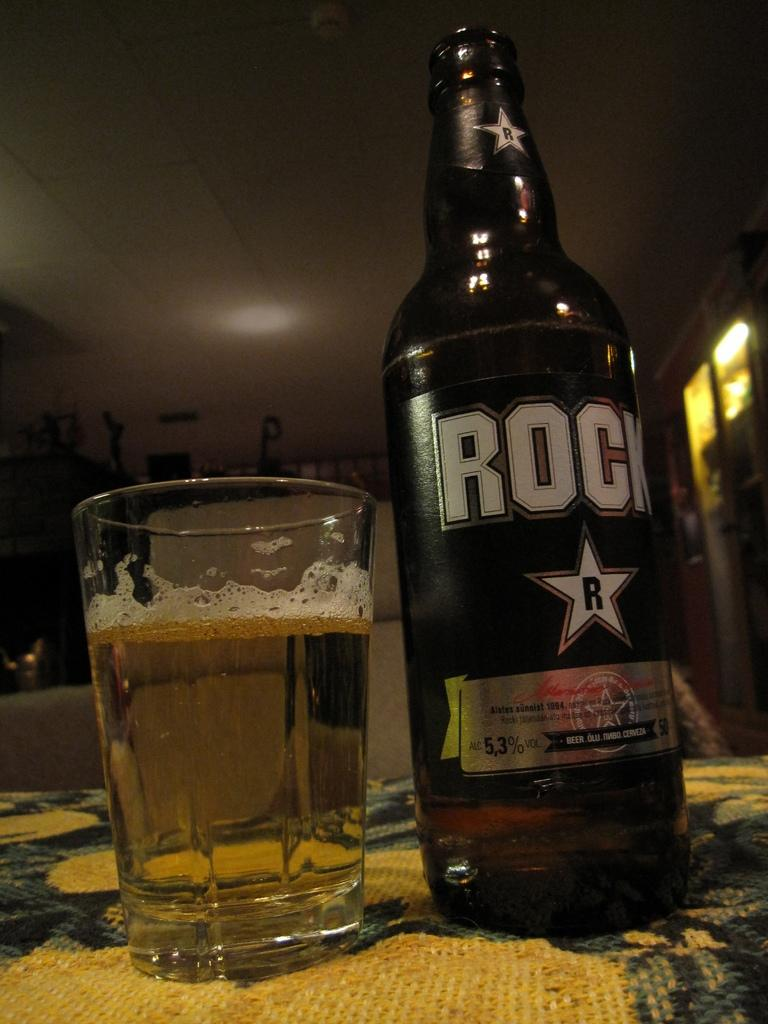<image>
Write a terse but informative summary of the picture. A glass of beer sits next to the bottle that says "Rock" on the label and is 5.3% alcohol. 